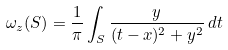<formula> <loc_0><loc_0><loc_500><loc_500>\omega _ { z } ( S ) = \frac { 1 } { \pi } \int _ { S } \frac { y } { ( t - x ) ^ { 2 } + y ^ { 2 } } \, d t</formula> 